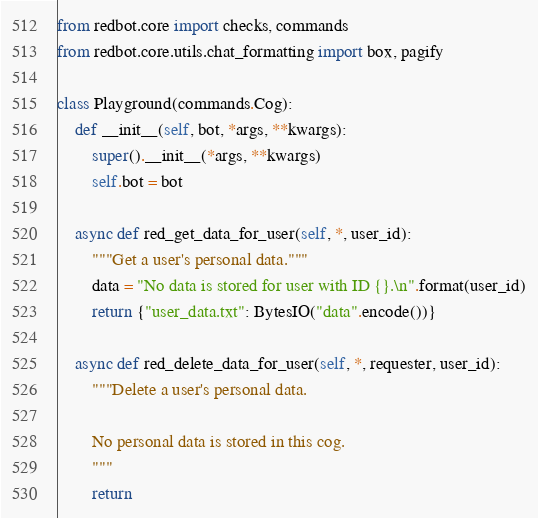Convert code to text. <code><loc_0><loc_0><loc_500><loc_500><_Python_>from redbot.core import checks, commands
from redbot.core.utils.chat_formatting import box, pagify

class Playground(commands.Cog):
    def __init__(self, bot, *args, **kwargs):
        super().__init__(*args, **kwargs)
        self.bot = bot

    async def red_get_data_for_user(self, *, user_id):
        """Get a user's personal data."""
        data = "No data is stored for user with ID {}.\n".format(user_id)
        return {"user_data.txt": BytesIO("data".encode())}

    async def red_delete_data_for_user(self, *, requester, user_id):
        """Delete a user's personal data.

        No personal data is stored in this cog.
        """
        return
</code> 